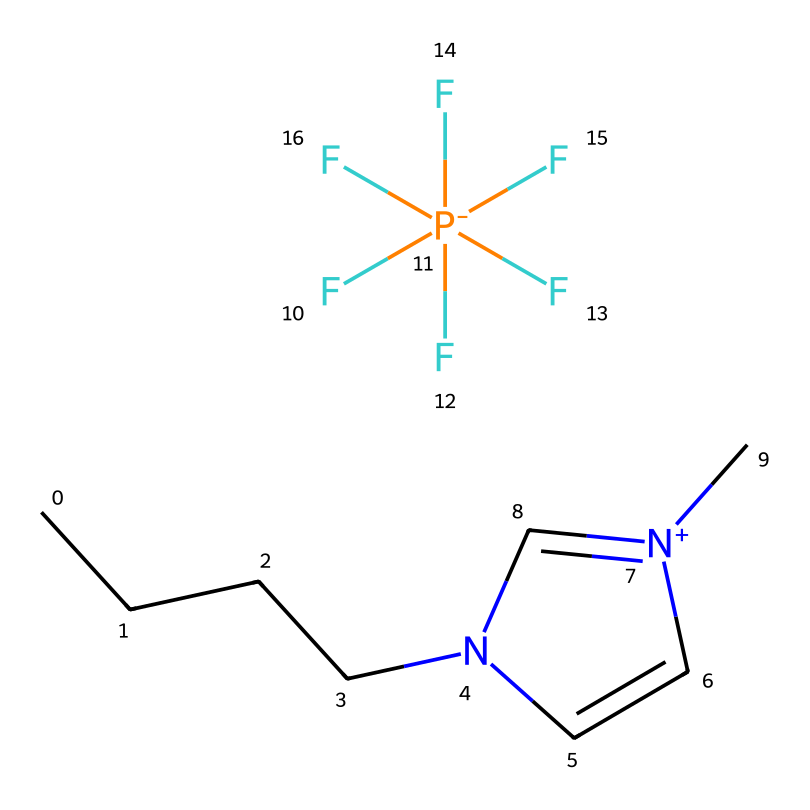What is the main nitrogen-containing structure in this ionic liquid? The chemical structure contains a pyridine-like nitrogen (denoted by 'n') within a five-membered ring. This is characteristic of the structure conducive to ionic liquid formation.
Answer: pyridine How many fluorine atoms are present in this compound? The structure shows a phosphorus atom being connected to five fluorine atoms (noted as F[P-](F)(F)(F)(F)F). Therefore, counting those gives five.
Answer: five What is the charge of the nitrogen atom in this ionic liquid? The nitrogen atom is indicated as positively charged (designated as '[n+]'), meaning it carries a positive charge in this ionic liquid.
Answer: positive Which functional group is primarily responsible for the ionic properties of this chemical? The presence of the 'n+' indicates the quaternary ammonium structure, which is known to have distinguishing ionic properties in ionic liquids.
Answer: quaternary ammonium What effect does the long hydrocarbon chain have on the properties of this ionic liquid? The long carbon chain ('CCCC') contributes to lower volatility and increased thermal stability, typical of ionic liquids' physical properties.
Answer: low volatility What type of ion is represented by the 'F[P-](F)(F)(F)(F)F' part? This segment represents a fluorinated phosphonium ion, which is crucial in providing the ionic nature of the liquid.
Answer: phosphonium ion 